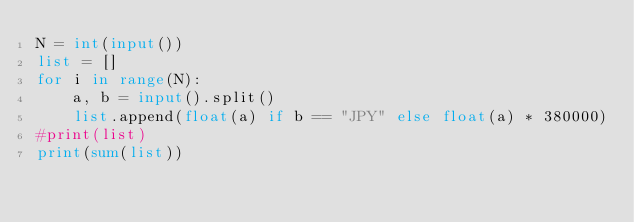<code> <loc_0><loc_0><loc_500><loc_500><_Python_>N = int(input())
list = []
for i in range(N):
    a, b = input().split()
    list.append(float(a) if b == "JPY" else float(a) * 380000)
#print(list)
print(sum(list))
</code> 